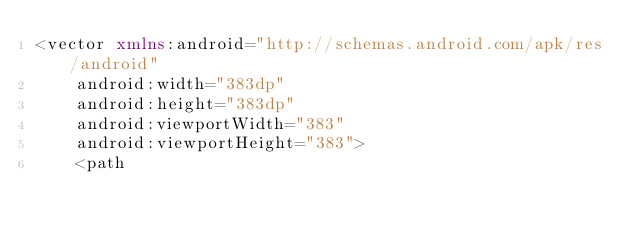<code> <loc_0><loc_0><loc_500><loc_500><_XML_><vector xmlns:android="http://schemas.android.com/apk/res/android"
    android:width="383dp"
    android:height="383dp"
    android:viewportWidth="383"
    android:viewportHeight="383">
    <path</code> 